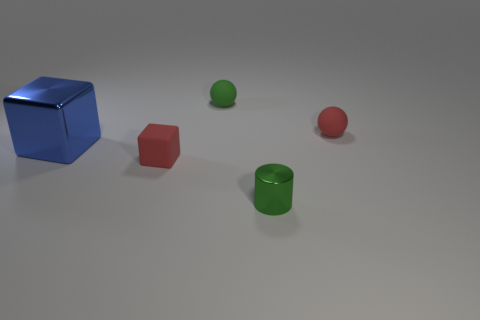Add 3 blue things. How many objects exist? 8 Subtract all blocks. How many objects are left? 3 Add 2 big cyan spheres. How many big cyan spheres exist? 2 Subtract 0 green blocks. How many objects are left? 5 Subtract all blue metal objects. Subtract all small cylinders. How many objects are left? 3 Add 5 rubber balls. How many rubber balls are left? 7 